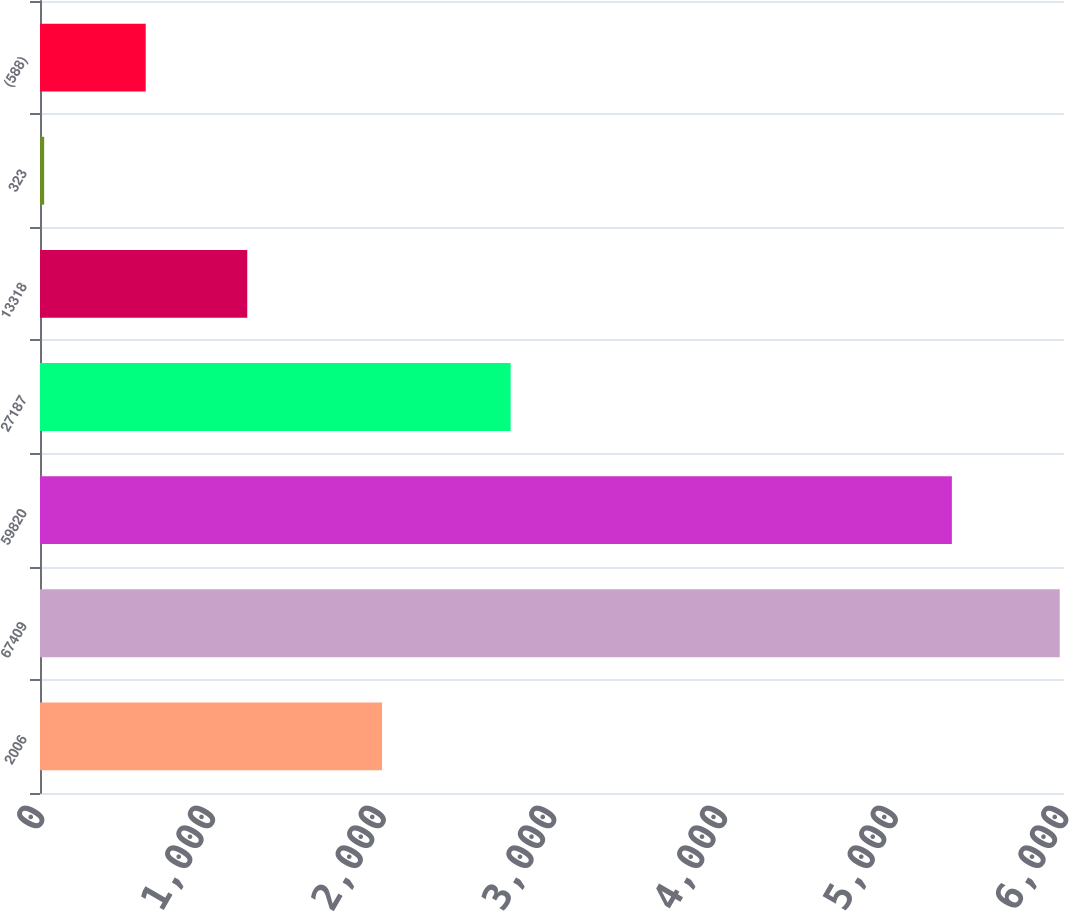Convert chart to OTSL. <chart><loc_0><loc_0><loc_500><loc_500><bar_chart><fcel>2006<fcel>67409<fcel>59820<fcel>27187<fcel>13318<fcel>323<fcel>(588)<nl><fcel>2004<fcel>5975.1<fcel>5343<fcel>2757.7<fcel>1214.46<fcel>24.3<fcel>619.38<nl></chart> 